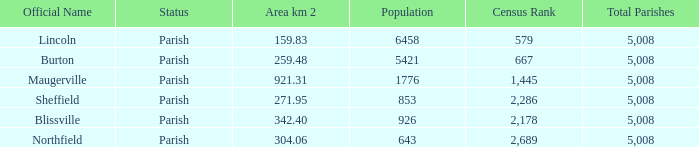What is the status(es) of the place with an area of 304.06 km2? Parish. 